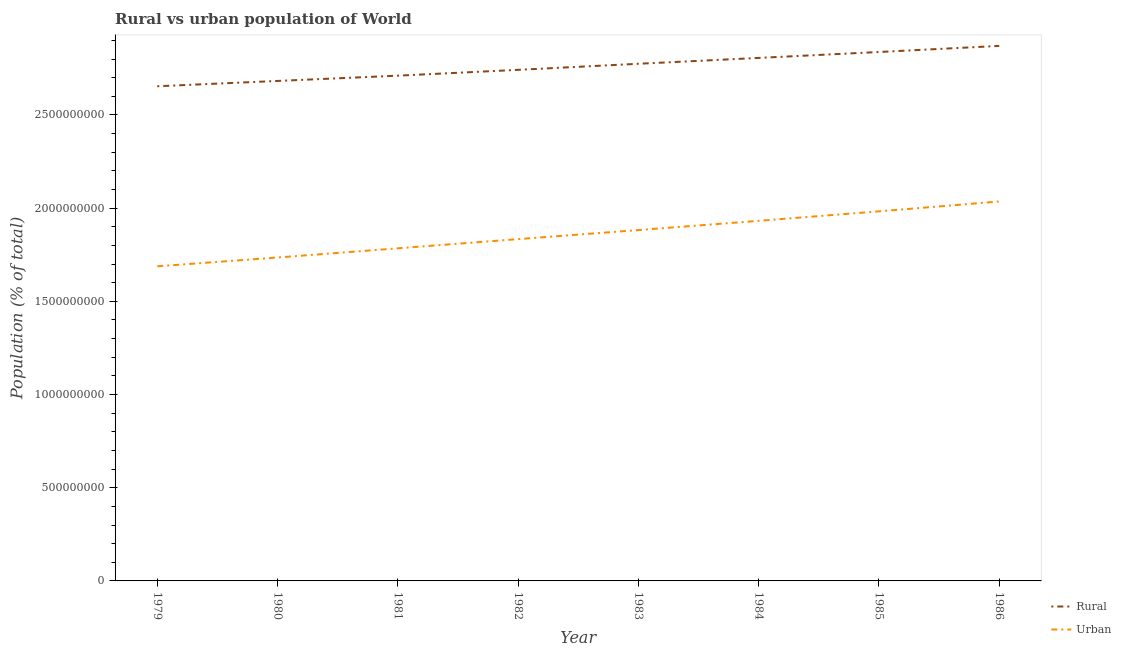Does the line corresponding to urban population density intersect with the line corresponding to rural population density?
Offer a terse response. No. Is the number of lines equal to the number of legend labels?
Provide a succinct answer. Yes. What is the rural population density in 1980?
Offer a very short reply. 2.68e+09. Across all years, what is the maximum rural population density?
Ensure brevity in your answer.  2.87e+09. Across all years, what is the minimum rural population density?
Give a very brief answer. 2.65e+09. In which year was the rural population density maximum?
Provide a succinct answer. 1986. In which year was the rural population density minimum?
Offer a terse response. 1979. What is the total urban population density in the graph?
Ensure brevity in your answer.  1.49e+1. What is the difference between the rural population density in 1980 and that in 1981?
Make the answer very short. -2.83e+07. What is the difference between the urban population density in 1979 and the rural population density in 1982?
Give a very brief answer. -1.05e+09. What is the average rural population density per year?
Ensure brevity in your answer.  2.76e+09. In the year 1983, what is the difference between the urban population density and rural population density?
Keep it short and to the point. -8.92e+08. In how many years, is the urban population density greater than 2400000000 %?
Your answer should be compact. 0. What is the ratio of the urban population density in 1981 to that in 1983?
Provide a short and direct response. 0.95. What is the difference between the highest and the second highest urban population density?
Give a very brief answer. 5.29e+07. What is the difference between the highest and the lowest rural population density?
Keep it short and to the point. 2.17e+08. Is the sum of the urban population density in 1980 and 1985 greater than the maximum rural population density across all years?
Your answer should be very brief. Yes. What is the difference between two consecutive major ticks on the Y-axis?
Make the answer very short. 5.00e+08. Are the values on the major ticks of Y-axis written in scientific E-notation?
Make the answer very short. No. Does the graph contain grids?
Ensure brevity in your answer.  No. How many legend labels are there?
Provide a succinct answer. 2. What is the title of the graph?
Provide a succinct answer. Rural vs urban population of World. What is the label or title of the X-axis?
Make the answer very short. Year. What is the label or title of the Y-axis?
Give a very brief answer. Population (% of total). What is the Population (% of total) in Rural in 1979?
Give a very brief answer. 2.65e+09. What is the Population (% of total) in Urban in 1979?
Keep it short and to the point. 1.69e+09. What is the Population (% of total) in Rural in 1980?
Your response must be concise. 2.68e+09. What is the Population (% of total) of Urban in 1980?
Make the answer very short. 1.74e+09. What is the Population (% of total) in Rural in 1981?
Make the answer very short. 2.71e+09. What is the Population (% of total) of Urban in 1981?
Offer a terse response. 1.78e+09. What is the Population (% of total) of Rural in 1982?
Make the answer very short. 2.74e+09. What is the Population (% of total) in Urban in 1982?
Provide a succinct answer. 1.83e+09. What is the Population (% of total) in Rural in 1983?
Your answer should be compact. 2.77e+09. What is the Population (% of total) of Urban in 1983?
Offer a terse response. 1.88e+09. What is the Population (% of total) of Rural in 1984?
Your answer should be compact. 2.81e+09. What is the Population (% of total) in Urban in 1984?
Offer a terse response. 1.93e+09. What is the Population (% of total) in Rural in 1985?
Keep it short and to the point. 2.84e+09. What is the Population (% of total) of Urban in 1985?
Make the answer very short. 1.98e+09. What is the Population (% of total) in Rural in 1986?
Offer a terse response. 2.87e+09. What is the Population (% of total) of Urban in 1986?
Ensure brevity in your answer.  2.04e+09. Across all years, what is the maximum Population (% of total) of Rural?
Ensure brevity in your answer.  2.87e+09. Across all years, what is the maximum Population (% of total) in Urban?
Offer a very short reply. 2.04e+09. Across all years, what is the minimum Population (% of total) of Rural?
Ensure brevity in your answer.  2.65e+09. Across all years, what is the minimum Population (% of total) of Urban?
Ensure brevity in your answer.  1.69e+09. What is the total Population (% of total) in Rural in the graph?
Your response must be concise. 2.21e+1. What is the total Population (% of total) of Urban in the graph?
Your answer should be very brief. 1.49e+1. What is the difference between the Population (% of total) in Rural in 1979 and that in 1980?
Keep it short and to the point. -2.85e+07. What is the difference between the Population (% of total) of Urban in 1979 and that in 1980?
Make the answer very short. -4.73e+07. What is the difference between the Population (% of total) in Rural in 1979 and that in 1981?
Ensure brevity in your answer.  -5.68e+07. What is the difference between the Population (% of total) of Urban in 1979 and that in 1981?
Your answer should be very brief. -9.66e+07. What is the difference between the Population (% of total) of Rural in 1979 and that in 1982?
Ensure brevity in your answer.  -8.81e+07. What is the difference between the Population (% of total) in Urban in 1979 and that in 1982?
Your answer should be very brief. -1.46e+08. What is the difference between the Population (% of total) of Rural in 1979 and that in 1983?
Offer a very short reply. -1.21e+08. What is the difference between the Population (% of total) in Urban in 1979 and that in 1983?
Offer a very short reply. -1.94e+08. What is the difference between the Population (% of total) in Rural in 1979 and that in 1984?
Your answer should be very brief. -1.52e+08. What is the difference between the Population (% of total) in Urban in 1979 and that in 1984?
Provide a succinct answer. -2.44e+08. What is the difference between the Population (% of total) of Rural in 1979 and that in 1985?
Ensure brevity in your answer.  -1.84e+08. What is the difference between the Population (% of total) of Urban in 1979 and that in 1985?
Give a very brief answer. -2.95e+08. What is the difference between the Population (% of total) of Rural in 1979 and that in 1986?
Offer a terse response. -2.17e+08. What is the difference between the Population (% of total) of Urban in 1979 and that in 1986?
Give a very brief answer. -3.48e+08. What is the difference between the Population (% of total) in Rural in 1980 and that in 1981?
Make the answer very short. -2.83e+07. What is the difference between the Population (% of total) in Urban in 1980 and that in 1981?
Make the answer very short. -4.93e+07. What is the difference between the Population (% of total) in Rural in 1980 and that in 1982?
Your answer should be very brief. -5.95e+07. What is the difference between the Population (% of total) of Urban in 1980 and that in 1982?
Offer a very short reply. -9.86e+07. What is the difference between the Population (% of total) of Rural in 1980 and that in 1983?
Ensure brevity in your answer.  -9.21e+07. What is the difference between the Population (% of total) in Urban in 1980 and that in 1983?
Offer a very short reply. -1.47e+08. What is the difference between the Population (% of total) in Rural in 1980 and that in 1984?
Ensure brevity in your answer.  -1.24e+08. What is the difference between the Population (% of total) of Urban in 1980 and that in 1984?
Provide a succinct answer. -1.97e+08. What is the difference between the Population (% of total) of Rural in 1980 and that in 1985?
Offer a very short reply. -1.55e+08. What is the difference between the Population (% of total) in Urban in 1980 and that in 1985?
Make the answer very short. -2.48e+08. What is the difference between the Population (% of total) in Rural in 1980 and that in 1986?
Your response must be concise. -1.88e+08. What is the difference between the Population (% of total) of Urban in 1980 and that in 1986?
Your response must be concise. -3.01e+08. What is the difference between the Population (% of total) of Rural in 1981 and that in 1982?
Offer a very short reply. -3.13e+07. What is the difference between the Population (% of total) in Urban in 1981 and that in 1982?
Give a very brief answer. -4.93e+07. What is the difference between the Population (% of total) in Rural in 1981 and that in 1983?
Your response must be concise. -6.38e+07. What is the difference between the Population (% of total) of Urban in 1981 and that in 1983?
Offer a very short reply. -9.79e+07. What is the difference between the Population (% of total) in Rural in 1981 and that in 1984?
Offer a very short reply. -9.52e+07. What is the difference between the Population (% of total) of Urban in 1981 and that in 1984?
Provide a short and direct response. -1.47e+08. What is the difference between the Population (% of total) in Rural in 1981 and that in 1985?
Give a very brief answer. -1.27e+08. What is the difference between the Population (% of total) in Urban in 1981 and that in 1985?
Offer a terse response. -1.98e+08. What is the difference between the Population (% of total) in Rural in 1981 and that in 1986?
Make the answer very short. -1.60e+08. What is the difference between the Population (% of total) of Urban in 1981 and that in 1986?
Your response must be concise. -2.51e+08. What is the difference between the Population (% of total) of Rural in 1982 and that in 1983?
Your response must be concise. -3.26e+07. What is the difference between the Population (% of total) of Urban in 1982 and that in 1983?
Provide a succinct answer. -4.86e+07. What is the difference between the Population (% of total) of Rural in 1982 and that in 1984?
Keep it short and to the point. -6.40e+07. What is the difference between the Population (% of total) of Urban in 1982 and that in 1984?
Provide a short and direct response. -9.81e+07. What is the difference between the Population (% of total) in Rural in 1982 and that in 1985?
Ensure brevity in your answer.  -9.58e+07. What is the difference between the Population (% of total) of Urban in 1982 and that in 1985?
Offer a very short reply. -1.49e+08. What is the difference between the Population (% of total) in Rural in 1982 and that in 1986?
Offer a terse response. -1.28e+08. What is the difference between the Population (% of total) of Urban in 1982 and that in 1986?
Make the answer very short. -2.02e+08. What is the difference between the Population (% of total) in Rural in 1983 and that in 1984?
Make the answer very short. -3.14e+07. What is the difference between the Population (% of total) of Urban in 1983 and that in 1984?
Offer a terse response. -4.95e+07. What is the difference between the Population (% of total) of Rural in 1983 and that in 1985?
Your response must be concise. -6.32e+07. What is the difference between the Population (% of total) of Urban in 1983 and that in 1985?
Your answer should be compact. -1.00e+08. What is the difference between the Population (% of total) of Rural in 1983 and that in 1986?
Your answer should be very brief. -9.59e+07. What is the difference between the Population (% of total) of Urban in 1983 and that in 1986?
Your answer should be very brief. -1.53e+08. What is the difference between the Population (% of total) of Rural in 1984 and that in 1985?
Offer a very short reply. -3.18e+07. What is the difference between the Population (% of total) of Urban in 1984 and that in 1985?
Make the answer very short. -5.09e+07. What is the difference between the Population (% of total) in Rural in 1984 and that in 1986?
Provide a short and direct response. -6.45e+07. What is the difference between the Population (% of total) of Urban in 1984 and that in 1986?
Make the answer very short. -1.04e+08. What is the difference between the Population (% of total) in Rural in 1985 and that in 1986?
Make the answer very short. -3.27e+07. What is the difference between the Population (% of total) in Urban in 1985 and that in 1986?
Offer a very short reply. -5.29e+07. What is the difference between the Population (% of total) of Rural in 1979 and the Population (% of total) of Urban in 1980?
Give a very brief answer. 9.19e+08. What is the difference between the Population (% of total) in Rural in 1979 and the Population (% of total) in Urban in 1981?
Make the answer very short. 8.69e+08. What is the difference between the Population (% of total) of Rural in 1979 and the Population (% of total) of Urban in 1982?
Ensure brevity in your answer.  8.20e+08. What is the difference between the Population (% of total) of Rural in 1979 and the Population (% of total) of Urban in 1983?
Your answer should be very brief. 7.71e+08. What is the difference between the Population (% of total) in Rural in 1979 and the Population (% of total) in Urban in 1984?
Keep it short and to the point. 7.22e+08. What is the difference between the Population (% of total) of Rural in 1979 and the Population (% of total) of Urban in 1985?
Give a very brief answer. 6.71e+08. What is the difference between the Population (% of total) in Rural in 1979 and the Population (% of total) in Urban in 1986?
Your answer should be compact. 6.18e+08. What is the difference between the Population (% of total) in Rural in 1980 and the Population (% of total) in Urban in 1981?
Offer a terse response. 8.98e+08. What is the difference between the Population (% of total) of Rural in 1980 and the Population (% of total) of Urban in 1982?
Keep it short and to the point. 8.49e+08. What is the difference between the Population (% of total) in Rural in 1980 and the Population (% of total) in Urban in 1983?
Offer a very short reply. 8.00e+08. What is the difference between the Population (% of total) in Rural in 1980 and the Population (% of total) in Urban in 1984?
Keep it short and to the point. 7.51e+08. What is the difference between the Population (% of total) of Rural in 1980 and the Population (% of total) of Urban in 1985?
Offer a terse response. 7.00e+08. What is the difference between the Population (% of total) of Rural in 1980 and the Population (% of total) of Urban in 1986?
Your response must be concise. 6.47e+08. What is the difference between the Population (% of total) of Rural in 1981 and the Population (% of total) of Urban in 1982?
Provide a succinct answer. 8.77e+08. What is the difference between the Population (% of total) of Rural in 1981 and the Population (% of total) of Urban in 1983?
Your answer should be compact. 8.28e+08. What is the difference between the Population (% of total) in Rural in 1981 and the Population (% of total) in Urban in 1984?
Provide a short and direct response. 7.79e+08. What is the difference between the Population (% of total) in Rural in 1981 and the Population (% of total) in Urban in 1985?
Make the answer very short. 7.28e+08. What is the difference between the Population (% of total) of Rural in 1981 and the Population (% of total) of Urban in 1986?
Offer a very short reply. 6.75e+08. What is the difference between the Population (% of total) of Rural in 1982 and the Population (% of total) of Urban in 1983?
Your response must be concise. 8.60e+08. What is the difference between the Population (% of total) of Rural in 1982 and the Population (% of total) of Urban in 1984?
Your answer should be very brief. 8.10e+08. What is the difference between the Population (% of total) in Rural in 1982 and the Population (% of total) in Urban in 1985?
Provide a succinct answer. 7.59e+08. What is the difference between the Population (% of total) of Rural in 1982 and the Population (% of total) of Urban in 1986?
Offer a terse response. 7.06e+08. What is the difference between the Population (% of total) of Rural in 1983 and the Population (% of total) of Urban in 1984?
Your answer should be compact. 8.43e+08. What is the difference between the Population (% of total) of Rural in 1983 and the Population (% of total) of Urban in 1985?
Your answer should be compact. 7.92e+08. What is the difference between the Population (% of total) in Rural in 1983 and the Population (% of total) in Urban in 1986?
Keep it short and to the point. 7.39e+08. What is the difference between the Population (% of total) of Rural in 1984 and the Population (% of total) of Urban in 1985?
Give a very brief answer. 8.23e+08. What is the difference between the Population (% of total) in Rural in 1984 and the Population (% of total) in Urban in 1986?
Provide a succinct answer. 7.70e+08. What is the difference between the Population (% of total) in Rural in 1985 and the Population (% of total) in Urban in 1986?
Give a very brief answer. 8.02e+08. What is the average Population (% of total) in Rural per year?
Your answer should be very brief. 2.76e+09. What is the average Population (% of total) in Urban per year?
Provide a short and direct response. 1.86e+09. In the year 1979, what is the difference between the Population (% of total) of Rural and Population (% of total) of Urban?
Keep it short and to the point. 9.66e+08. In the year 1980, what is the difference between the Population (% of total) in Rural and Population (% of total) in Urban?
Your answer should be very brief. 9.47e+08. In the year 1981, what is the difference between the Population (% of total) in Rural and Population (% of total) in Urban?
Provide a short and direct response. 9.26e+08. In the year 1982, what is the difference between the Population (% of total) of Rural and Population (% of total) of Urban?
Your response must be concise. 9.08e+08. In the year 1983, what is the difference between the Population (% of total) in Rural and Population (% of total) in Urban?
Provide a succinct answer. 8.92e+08. In the year 1984, what is the difference between the Population (% of total) in Rural and Population (% of total) in Urban?
Your response must be concise. 8.74e+08. In the year 1985, what is the difference between the Population (% of total) in Rural and Population (% of total) in Urban?
Provide a succinct answer. 8.55e+08. In the year 1986, what is the difference between the Population (% of total) in Rural and Population (% of total) in Urban?
Your answer should be compact. 8.35e+08. What is the ratio of the Population (% of total) of Rural in 1979 to that in 1980?
Offer a very short reply. 0.99. What is the ratio of the Population (% of total) in Urban in 1979 to that in 1980?
Provide a short and direct response. 0.97. What is the ratio of the Population (% of total) of Rural in 1979 to that in 1981?
Provide a short and direct response. 0.98. What is the ratio of the Population (% of total) in Urban in 1979 to that in 1981?
Offer a terse response. 0.95. What is the ratio of the Population (% of total) of Rural in 1979 to that in 1982?
Ensure brevity in your answer.  0.97. What is the ratio of the Population (% of total) of Urban in 1979 to that in 1982?
Provide a short and direct response. 0.92. What is the ratio of the Population (% of total) of Rural in 1979 to that in 1983?
Provide a succinct answer. 0.96. What is the ratio of the Population (% of total) in Urban in 1979 to that in 1983?
Ensure brevity in your answer.  0.9. What is the ratio of the Population (% of total) in Rural in 1979 to that in 1984?
Give a very brief answer. 0.95. What is the ratio of the Population (% of total) in Urban in 1979 to that in 1984?
Your response must be concise. 0.87. What is the ratio of the Population (% of total) in Rural in 1979 to that in 1985?
Keep it short and to the point. 0.94. What is the ratio of the Population (% of total) in Urban in 1979 to that in 1985?
Keep it short and to the point. 0.85. What is the ratio of the Population (% of total) of Rural in 1979 to that in 1986?
Your answer should be very brief. 0.92. What is the ratio of the Population (% of total) in Urban in 1979 to that in 1986?
Provide a succinct answer. 0.83. What is the ratio of the Population (% of total) in Urban in 1980 to that in 1981?
Offer a very short reply. 0.97. What is the ratio of the Population (% of total) of Rural in 1980 to that in 1982?
Ensure brevity in your answer.  0.98. What is the ratio of the Population (% of total) in Urban in 1980 to that in 1982?
Provide a short and direct response. 0.95. What is the ratio of the Population (% of total) of Rural in 1980 to that in 1983?
Give a very brief answer. 0.97. What is the ratio of the Population (% of total) in Urban in 1980 to that in 1983?
Your answer should be very brief. 0.92. What is the ratio of the Population (% of total) in Rural in 1980 to that in 1984?
Provide a short and direct response. 0.96. What is the ratio of the Population (% of total) in Urban in 1980 to that in 1984?
Give a very brief answer. 0.9. What is the ratio of the Population (% of total) in Rural in 1980 to that in 1985?
Your response must be concise. 0.95. What is the ratio of the Population (% of total) of Urban in 1980 to that in 1985?
Provide a succinct answer. 0.88. What is the ratio of the Population (% of total) in Rural in 1980 to that in 1986?
Ensure brevity in your answer.  0.93. What is the ratio of the Population (% of total) of Urban in 1980 to that in 1986?
Offer a terse response. 0.85. What is the ratio of the Population (% of total) in Urban in 1981 to that in 1982?
Ensure brevity in your answer.  0.97. What is the ratio of the Population (% of total) of Rural in 1981 to that in 1983?
Keep it short and to the point. 0.98. What is the ratio of the Population (% of total) in Urban in 1981 to that in 1983?
Offer a very short reply. 0.95. What is the ratio of the Population (% of total) in Rural in 1981 to that in 1984?
Your response must be concise. 0.97. What is the ratio of the Population (% of total) in Urban in 1981 to that in 1984?
Offer a terse response. 0.92. What is the ratio of the Population (% of total) of Rural in 1981 to that in 1985?
Ensure brevity in your answer.  0.96. What is the ratio of the Population (% of total) of Urban in 1981 to that in 1985?
Your answer should be very brief. 0.9. What is the ratio of the Population (% of total) of Urban in 1981 to that in 1986?
Your answer should be very brief. 0.88. What is the ratio of the Population (% of total) of Rural in 1982 to that in 1983?
Provide a short and direct response. 0.99. What is the ratio of the Population (% of total) of Urban in 1982 to that in 1983?
Give a very brief answer. 0.97. What is the ratio of the Population (% of total) in Rural in 1982 to that in 1984?
Offer a very short reply. 0.98. What is the ratio of the Population (% of total) of Urban in 1982 to that in 1984?
Provide a succinct answer. 0.95. What is the ratio of the Population (% of total) of Rural in 1982 to that in 1985?
Offer a terse response. 0.97. What is the ratio of the Population (% of total) of Urban in 1982 to that in 1985?
Ensure brevity in your answer.  0.92. What is the ratio of the Population (% of total) of Rural in 1982 to that in 1986?
Your answer should be compact. 0.96. What is the ratio of the Population (% of total) in Urban in 1982 to that in 1986?
Provide a short and direct response. 0.9. What is the ratio of the Population (% of total) of Rural in 1983 to that in 1984?
Keep it short and to the point. 0.99. What is the ratio of the Population (% of total) in Urban in 1983 to that in 1984?
Your response must be concise. 0.97. What is the ratio of the Population (% of total) of Rural in 1983 to that in 1985?
Provide a short and direct response. 0.98. What is the ratio of the Population (% of total) in Urban in 1983 to that in 1985?
Offer a very short reply. 0.95. What is the ratio of the Population (% of total) in Rural in 1983 to that in 1986?
Provide a succinct answer. 0.97. What is the ratio of the Population (% of total) in Urban in 1983 to that in 1986?
Make the answer very short. 0.92. What is the ratio of the Population (% of total) of Rural in 1984 to that in 1985?
Provide a short and direct response. 0.99. What is the ratio of the Population (% of total) of Urban in 1984 to that in 1985?
Ensure brevity in your answer.  0.97. What is the ratio of the Population (% of total) in Rural in 1984 to that in 1986?
Keep it short and to the point. 0.98. What is the ratio of the Population (% of total) in Urban in 1984 to that in 1986?
Provide a short and direct response. 0.95. What is the ratio of the Population (% of total) in Urban in 1985 to that in 1986?
Your answer should be very brief. 0.97. What is the difference between the highest and the second highest Population (% of total) in Rural?
Ensure brevity in your answer.  3.27e+07. What is the difference between the highest and the second highest Population (% of total) of Urban?
Ensure brevity in your answer.  5.29e+07. What is the difference between the highest and the lowest Population (% of total) of Rural?
Make the answer very short. 2.17e+08. What is the difference between the highest and the lowest Population (% of total) in Urban?
Ensure brevity in your answer.  3.48e+08. 